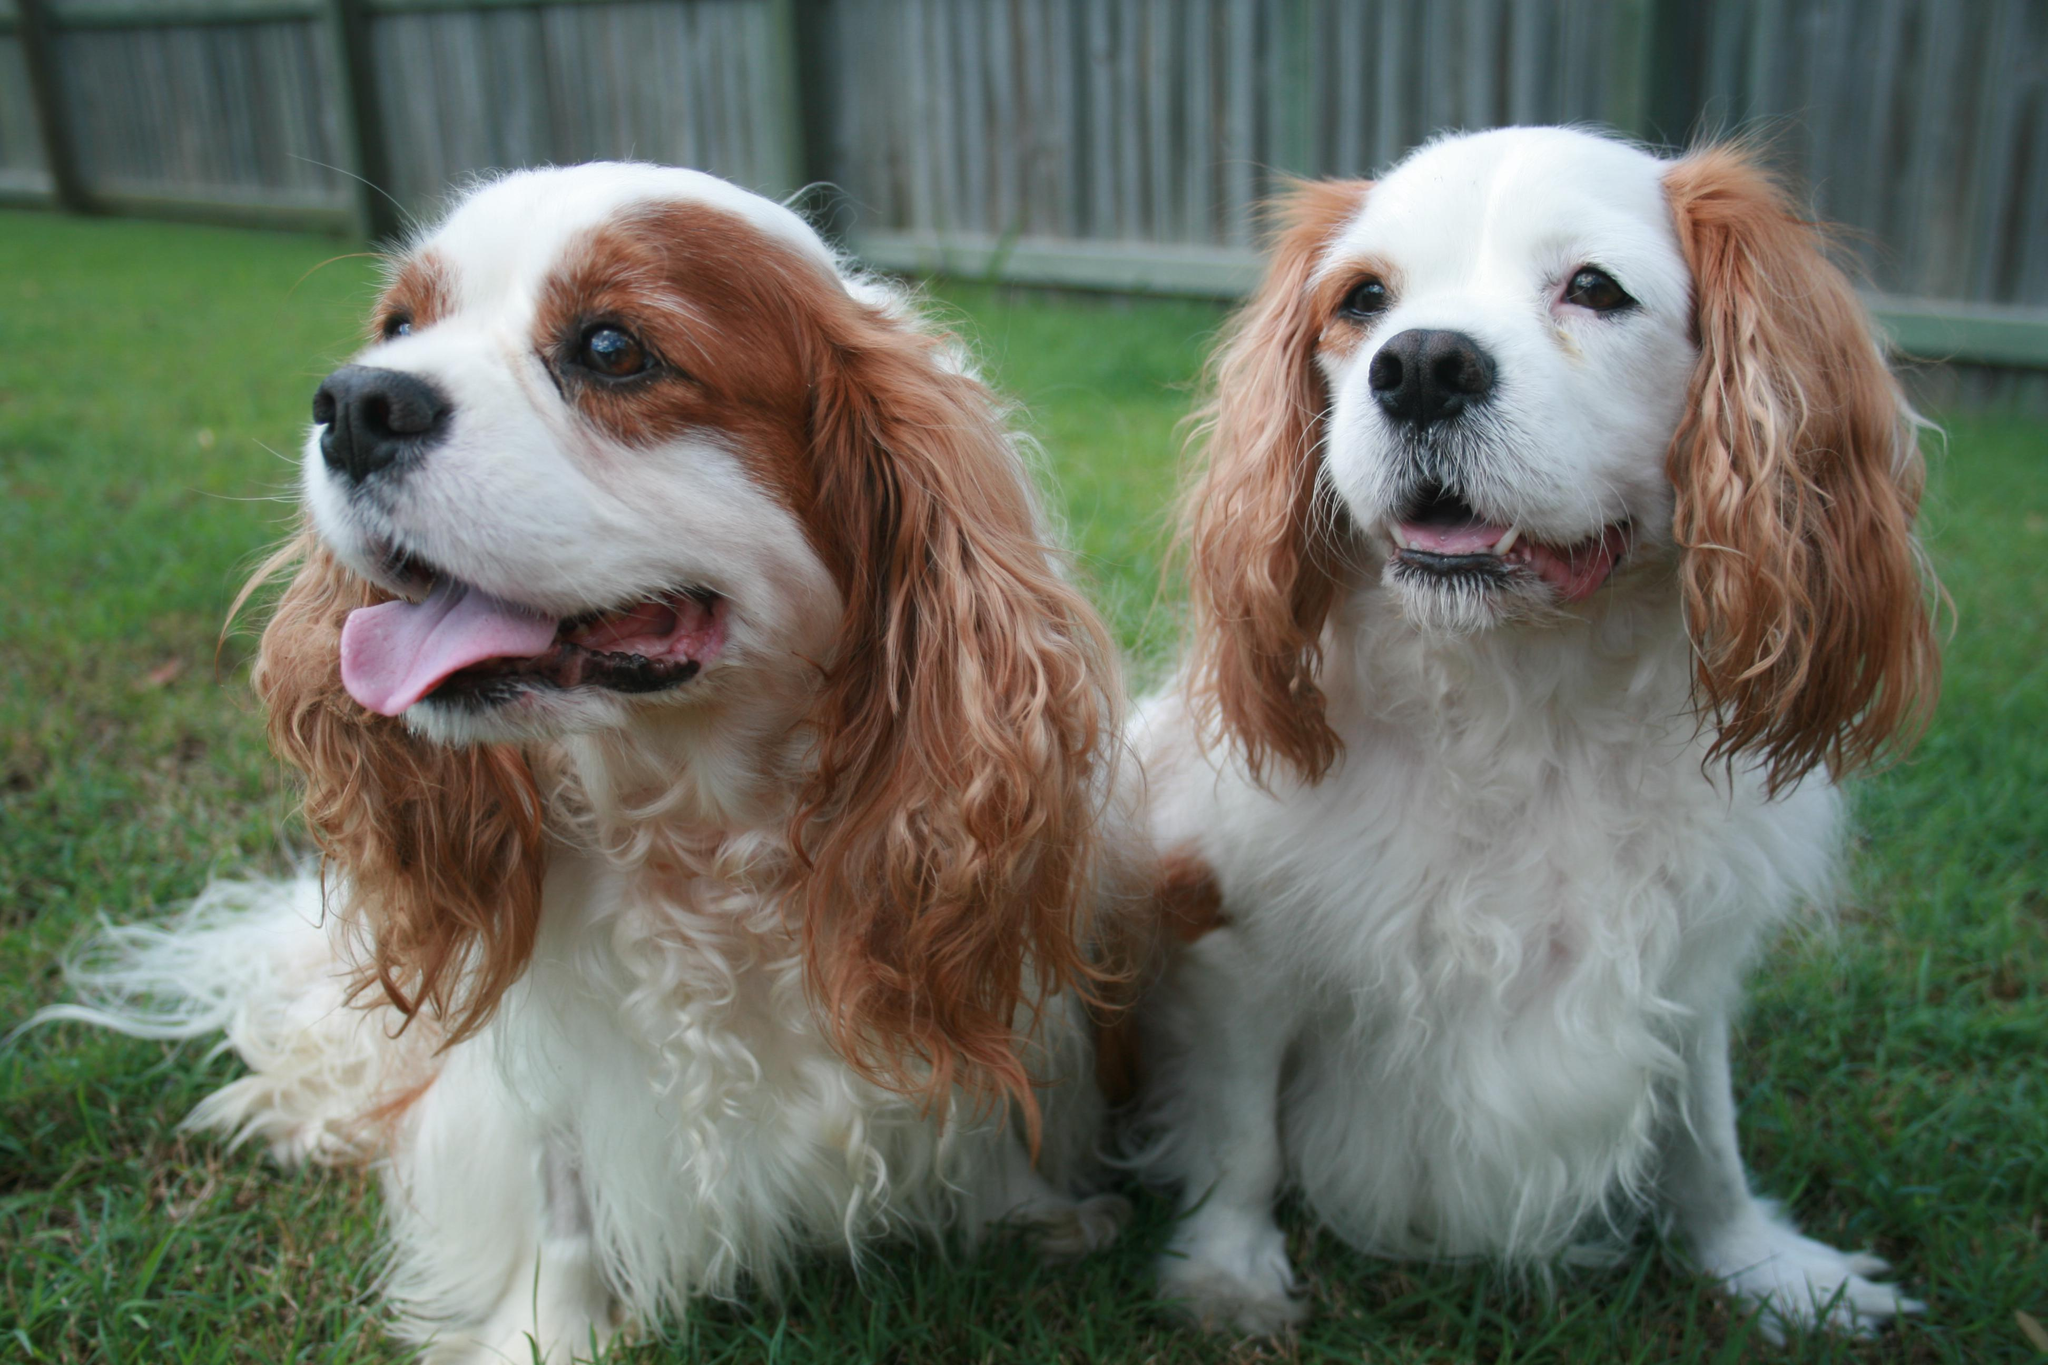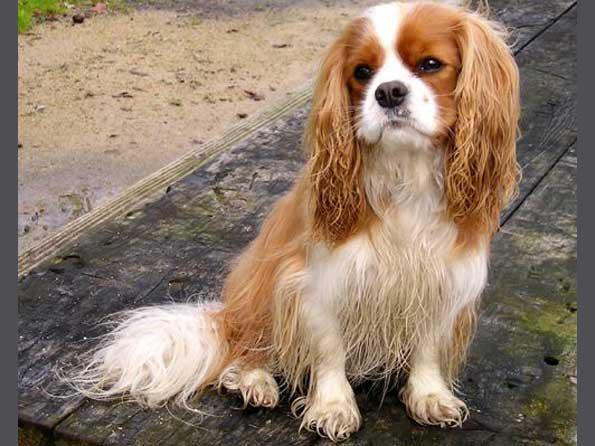The first image is the image on the left, the second image is the image on the right. Given the left and right images, does the statement "One image depicts exactly two dogs side by side on grass." hold true? Answer yes or no. Yes. 